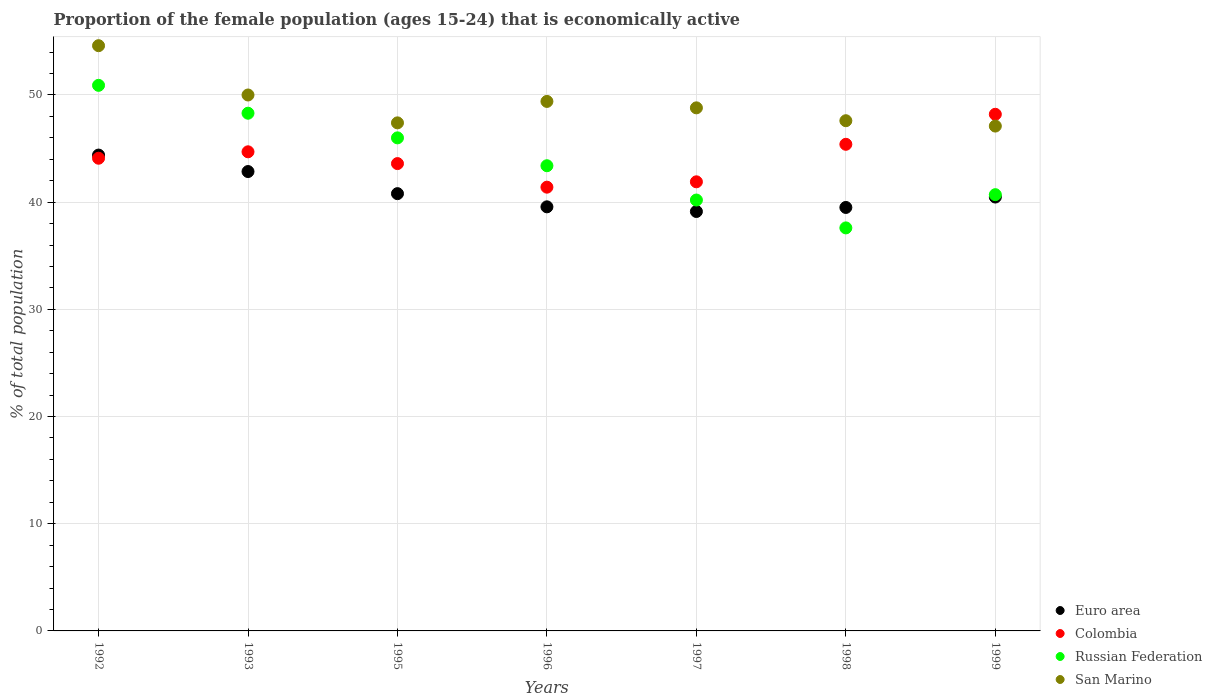How many different coloured dotlines are there?
Your response must be concise. 4. Is the number of dotlines equal to the number of legend labels?
Provide a short and direct response. Yes. What is the proportion of the female population that is economically active in Colombia in 1997?
Offer a terse response. 41.9. Across all years, what is the maximum proportion of the female population that is economically active in Colombia?
Your answer should be compact. 48.2. Across all years, what is the minimum proportion of the female population that is economically active in Euro area?
Your response must be concise. 39.13. In which year was the proportion of the female population that is economically active in San Marino minimum?
Your answer should be compact. 1999. What is the total proportion of the female population that is economically active in Colombia in the graph?
Give a very brief answer. 309.3. What is the difference between the proportion of the female population that is economically active in San Marino in 1993 and that in 1995?
Offer a terse response. 2.6. What is the average proportion of the female population that is economically active in Russian Federation per year?
Provide a short and direct response. 43.87. In the year 1999, what is the difference between the proportion of the female population that is economically active in Colombia and proportion of the female population that is economically active in San Marino?
Your response must be concise. 1.1. What is the ratio of the proportion of the female population that is economically active in Euro area in 1993 to that in 1996?
Give a very brief answer. 1.08. Is the difference between the proportion of the female population that is economically active in Colombia in 1998 and 1999 greater than the difference between the proportion of the female population that is economically active in San Marino in 1998 and 1999?
Your response must be concise. No. What is the difference between the highest and the second highest proportion of the female population that is economically active in Russian Federation?
Offer a very short reply. 2.6. What is the difference between the highest and the lowest proportion of the female population that is economically active in Colombia?
Offer a very short reply. 6.8. Does the proportion of the female population that is economically active in Colombia monotonically increase over the years?
Provide a succinct answer. No. How many dotlines are there?
Keep it short and to the point. 4. How many legend labels are there?
Make the answer very short. 4. What is the title of the graph?
Make the answer very short. Proportion of the female population (ages 15-24) that is economically active. Does "Liechtenstein" appear as one of the legend labels in the graph?
Provide a succinct answer. No. What is the label or title of the Y-axis?
Offer a terse response. % of total population. What is the % of total population in Euro area in 1992?
Provide a short and direct response. 44.39. What is the % of total population of Colombia in 1992?
Your answer should be very brief. 44.1. What is the % of total population in Russian Federation in 1992?
Offer a terse response. 50.9. What is the % of total population of San Marino in 1992?
Provide a short and direct response. 54.6. What is the % of total population of Euro area in 1993?
Offer a very short reply. 42.86. What is the % of total population of Colombia in 1993?
Offer a terse response. 44.7. What is the % of total population in Russian Federation in 1993?
Offer a very short reply. 48.3. What is the % of total population in Euro area in 1995?
Offer a very short reply. 40.8. What is the % of total population in Colombia in 1995?
Ensure brevity in your answer.  43.6. What is the % of total population of San Marino in 1995?
Offer a very short reply. 47.4. What is the % of total population in Euro area in 1996?
Your response must be concise. 39.57. What is the % of total population of Colombia in 1996?
Offer a terse response. 41.4. What is the % of total population in Russian Federation in 1996?
Provide a short and direct response. 43.4. What is the % of total population of San Marino in 1996?
Ensure brevity in your answer.  49.4. What is the % of total population in Euro area in 1997?
Your answer should be compact. 39.13. What is the % of total population of Colombia in 1997?
Your response must be concise. 41.9. What is the % of total population of Russian Federation in 1997?
Keep it short and to the point. 40.2. What is the % of total population in San Marino in 1997?
Ensure brevity in your answer.  48.8. What is the % of total population in Euro area in 1998?
Keep it short and to the point. 39.51. What is the % of total population in Colombia in 1998?
Keep it short and to the point. 45.4. What is the % of total population in Russian Federation in 1998?
Ensure brevity in your answer.  37.6. What is the % of total population of San Marino in 1998?
Your answer should be compact. 47.6. What is the % of total population in Euro area in 1999?
Offer a terse response. 40.48. What is the % of total population of Colombia in 1999?
Offer a terse response. 48.2. What is the % of total population in Russian Federation in 1999?
Keep it short and to the point. 40.7. What is the % of total population of San Marino in 1999?
Offer a terse response. 47.1. Across all years, what is the maximum % of total population in Euro area?
Your response must be concise. 44.39. Across all years, what is the maximum % of total population in Colombia?
Give a very brief answer. 48.2. Across all years, what is the maximum % of total population of Russian Federation?
Provide a short and direct response. 50.9. Across all years, what is the maximum % of total population in San Marino?
Your answer should be very brief. 54.6. Across all years, what is the minimum % of total population of Euro area?
Your response must be concise. 39.13. Across all years, what is the minimum % of total population in Colombia?
Ensure brevity in your answer.  41.4. Across all years, what is the minimum % of total population of Russian Federation?
Offer a terse response. 37.6. Across all years, what is the minimum % of total population in San Marino?
Provide a short and direct response. 47.1. What is the total % of total population of Euro area in the graph?
Make the answer very short. 286.73. What is the total % of total population in Colombia in the graph?
Your answer should be compact. 309.3. What is the total % of total population in Russian Federation in the graph?
Offer a terse response. 307.1. What is the total % of total population in San Marino in the graph?
Provide a succinct answer. 344.9. What is the difference between the % of total population of Euro area in 1992 and that in 1993?
Your answer should be very brief. 1.54. What is the difference between the % of total population in Colombia in 1992 and that in 1993?
Provide a succinct answer. -0.6. What is the difference between the % of total population of Russian Federation in 1992 and that in 1993?
Ensure brevity in your answer.  2.6. What is the difference between the % of total population of San Marino in 1992 and that in 1993?
Your response must be concise. 4.6. What is the difference between the % of total population in Euro area in 1992 and that in 1995?
Make the answer very short. 3.6. What is the difference between the % of total population in Colombia in 1992 and that in 1995?
Give a very brief answer. 0.5. What is the difference between the % of total population in Euro area in 1992 and that in 1996?
Keep it short and to the point. 4.83. What is the difference between the % of total population in Colombia in 1992 and that in 1996?
Your answer should be compact. 2.7. What is the difference between the % of total population of Euro area in 1992 and that in 1997?
Provide a succinct answer. 5.26. What is the difference between the % of total population in Colombia in 1992 and that in 1997?
Make the answer very short. 2.2. What is the difference between the % of total population of Euro area in 1992 and that in 1998?
Your answer should be very brief. 4.89. What is the difference between the % of total population in San Marino in 1992 and that in 1998?
Provide a short and direct response. 7. What is the difference between the % of total population in Euro area in 1992 and that in 1999?
Ensure brevity in your answer.  3.92. What is the difference between the % of total population of Euro area in 1993 and that in 1995?
Provide a short and direct response. 2.06. What is the difference between the % of total population of Colombia in 1993 and that in 1995?
Your response must be concise. 1.1. What is the difference between the % of total population in Russian Federation in 1993 and that in 1995?
Give a very brief answer. 2.3. What is the difference between the % of total population in Euro area in 1993 and that in 1996?
Your answer should be very brief. 3.29. What is the difference between the % of total population of Russian Federation in 1993 and that in 1996?
Provide a succinct answer. 4.9. What is the difference between the % of total population of Euro area in 1993 and that in 1997?
Ensure brevity in your answer.  3.73. What is the difference between the % of total population of Euro area in 1993 and that in 1998?
Your response must be concise. 3.35. What is the difference between the % of total population of Colombia in 1993 and that in 1998?
Give a very brief answer. -0.7. What is the difference between the % of total population of San Marino in 1993 and that in 1998?
Ensure brevity in your answer.  2.4. What is the difference between the % of total population of Euro area in 1993 and that in 1999?
Make the answer very short. 2.38. What is the difference between the % of total population in Colombia in 1993 and that in 1999?
Give a very brief answer. -3.5. What is the difference between the % of total population of Russian Federation in 1993 and that in 1999?
Ensure brevity in your answer.  7.6. What is the difference between the % of total population in San Marino in 1993 and that in 1999?
Give a very brief answer. 2.9. What is the difference between the % of total population in Euro area in 1995 and that in 1996?
Make the answer very short. 1.23. What is the difference between the % of total population in Euro area in 1995 and that in 1997?
Your answer should be compact. 1.67. What is the difference between the % of total population in Colombia in 1995 and that in 1997?
Provide a succinct answer. 1.7. What is the difference between the % of total population of Russian Federation in 1995 and that in 1997?
Provide a short and direct response. 5.8. What is the difference between the % of total population of Euro area in 1995 and that in 1998?
Your answer should be compact. 1.29. What is the difference between the % of total population in Colombia in 1995 and that in 1998?
Ensure brevity in your answer.  -1.8. What is the difference between the % of total population in San Marino in 1995 and that in 1998?
Give a very brief answer. -0.2. What is the difference between the % of total population of Euro area in 1995 and that in 1999?
Provide a succinct answer. 0.32. What is the difference between the % of total population in Colombia in 1995 and that in 1999?
Your response must be concise. -4.6. What is the difference between the % of total population in San Marino in 1995 and that in 1999?
Make the answer very short. 0.3. What is the difference between the % of total population in Euro area in 1996 and that in 1997?
Offer a terse response. 0.44. What is the difference between the % of total population in Colombia in 1996 and that in 1997?
Offer a terse response. -0.5. What is the difference between the % of total population of Russian Federation in 1996 and that in 1997?
Your response must be concise. 3.2. What is the difference between the % of total population of Euro area in 1996 and that in 1998?
Your answer should be very brief. 0.06. What is the difference between the % of total population of Colombia in 1996 and that in 1998?
Your response must be concise. -4. What is the difference between the % of total population in Russian Federation in 1996 and that in 1998?
Provide a short and direct response. 5.8. What is the difference between the % of total population in Euro area in 1996 and that in 1999?
Your answer should be compact. -0.91. What is the difference between the % of total population of Russian Federation in 1996 and that in 1999?
Ensure brevity in your answer.  2.7. What is the difference between the % of total population of Euro area in 1997 and that in 1998?
Provide a succinct answer. -0.38. What is the difference between the % of total population in San Marino in 1997 and that in 1998?
Your response must be concise. 1.2. What is the difference between the % of total population of Euro area in 1997 and that in 1999?
Your response must be concise. -1.35. What is the difference between the % of total population of Russian Federation in 1997 and that in 1999?
Your response must be concise. -0.5. What is the difference between the % of total population in Euro area in 1998 and that in 1999?
Give a very brief answer. -0.97. What is the difference between the % of total population in Colombia in 1998 and that in 1999?
Your answer should be very brief. -2.8. What is the difference between the % of total population in San Marino in 1998 and that in 1999?
Make the answer very short. 0.5. What is the difference between the % of total population of Euro area in 1992 and the % of total population of Colombia in 1993?
Your response must be concise. -0.31. What is the difference between the % of total population of Euro area in 1992 and the % of total population of Russian Federation in 1993?
Your response must be concise. -3.91. What is the difference between the % of total population of Euro area in 1992 and the % of total population of San Marino in 1993?
Make the answer very short. -5.61. What is the difference between the % of total population of Colombia in 1992 and the % of total population of Russian Federation in 1993?
Ensure brevity in your answer.  -4.2. What is the difference between the % of total population in Colombia in 1992 and the % of total population in San Marino in 1993?
Your answer should be compact. -5.9. What is the difference between the % of total population of Euro area in 1992 and the % of total population of Colombia in 1995?
Give a very brief answer. 0.79. What is the difference between the % of total population of Euro area in 1992 and the % of total population of Russian Federation in 1995?
Keep it short and to the point. -1.61. What is the difference between the % of total population in Euro area in 1992 and the % of total population in San Marino in 1995?
Provide a short and direct response. -3.01. What is the difference between the % of total population of Colombia in 1992 and the % of total population of Russian Federation in 1995?
Offer a very short reply. -1.9. What is the difference between the % of total population of Colombia in 1992 and the % of total population of San Marino in 1995?
Offer a terse response. -3.3. What is the difference between the % of total population in Russian Federation in 1992 and the % of total population in San Marino in 1995?
Make the answer very short. 3.5. What is the difference between the % of total population of Euro area in 1992 and the % of total population of Colombia in 1996?
Keep it short and to the point. 2.99. What is the difference between the % of total population of Euro area in 1992 and the % of total population of San Marino in 1996?
Offer a very short reply. -5.01. What is the difference between the % of total population of Russian Federation in 1992 and the % of total population of San Marino in 1996?
Ensure brevity in your answer.  1.5. What is the difference between the % of total population of Euro area in 1992 and the % of total population of Colombia in 1997?
Offer a terse response. 2.49. What is the difference between the % of total population of Euro area in 1992 and the % of total population of Russian Federation in 1997?
Give a very brief answer. 4.19. What is the difference between the % of total population of Euro area in 1992 and the % of total population of San Marino in 1997?
Make the answer very short. -4.41. What is the difference between the % of total population in Colombia in 1992 and the % of total population in Russian Federation in 1997?
Make the answer very short. 3.9. What is the difference between the % of total population in Euro area in 1992 and the % of total population in Colombia in 1998?
Give a very brief answer. -1.01. What is the difference between the % of total population in Euro area in 1992 and the % of total population in Russian Federation in 1998?
Make the answer very short. 6.79. What is the difference between the % of total population in Euro area in 1992 and the % of total population in San Marino in 1998?
Your response must be concise. -3.21. What is the difference between the % of total population in Colombia in 1992 and the % of total population in Russian Federation in 1998?
Give a very brief answer. 6.5. What is the difference between the % of total population of Euro area in 1992 and the % of total population of Colombia in 1999?
Your answer should be compact. -3.81. What is the difference between the % of total population in Euro area in 1992 and the % of total population in Russian Federation in 1999?
Ensure brevity in your answer.  3.69. What is the difference between the % of total population of Euro area in 1992 and the % of total population of San Marino in 1999?
Keep it short and to the point. -2.71. What is the difference between the % of total population of Colombia in 1992 and the % of total population of San Marino in 1999?
Provide a short and direct response. -3. What is the difference between the % of total population of Euro area in 1993 and the % of total population of Colombia in 1995?
Offer a very short reply. -0.74. What is the difference between the % of total population in Euro area in 1993 and the % of total population in Russian Federation in 1995?
Make the answer very short. -3.14. What is the difference between the % of total population in Euro area in 1993 and the % of total population in San Marino in 1995?
Give a very brief answer. -4.54. What is the difference between the % of total population of Colombia in 1993 and the % of total population of San Marino in 1995?
Keep it short and to the point. -2.7. What is the difference between the % of total population of Euro area in 1993 and the % of total population of Colombia in 1996?
Your answer should be very brief. 1.46. What is the difference between the % of total population of Euro area in 1993 and the % of total population of Russian Federation in 1996?
Your answer should be compact. -0.54. What is the difference between the % of total population of Euro area in 1993 and the % of total population of San Marino in 1996?
Offer a very short reply. -6.54. What is the difference between the % of total population of Colombia in 1993 and the % of total population of San Marino in 1996?
Give a very brief answer. -4.7. What is the difference between the % of total population of Russian Federation in 1993 and the % of total population of San Marino in 1996?
Offer a terse response. -1.1. What is the difference between the % of total population in Euro area in 1993 and the % of total population in Colombia in 1997?
Your answer should be compact. 0.96. What is the difference between the % of total population in Euro area in 1993 and the % of total population in Russian Federation in 1997?
Ensure brevity in your answer.  2.66. What is the difference between the % of total population of Euro area in 1993 and the % of total population of San Marino in 1997?
Ensure brevity in your answer.  -5.94. What is the difference between the % of total population of Colombia in 1993 and the % of total population of Russian Federation in 1997?
Offer a very short reply. 4.5. What is the difference between the % of total population in Colombia in 1993 and the % of total population in San Marino in 1997?
Offer a very short reply. -4.1. What is the difference between the % of total population in Russian Federation in 1993 and the % of total population in San Marino in 1997?
Offer a terse response. -0.5. What is the difference between the % of total population in Euro area in 1993 and the % of total population in Colombia in 1998?
Your answer should be very brief. -2.54. What is the difference between the % of total population in Euro area in 1993 and the % of total population in Russian Federation in 1998?
Give a very brief answer. 5.26. What is the difference between the % of total population of Euro area in 1993 and the % of total population of San Marino in 1998?
Provide a short and direct response. -4.74. What is the difference between the % of total population in Colombia in 1993 and the % of total population in Russian Federation in 1998?
Provide a succinct answer. 7.1. What is the difference between the % of total population in Colombia in 1993 and the % of total population in San Marino in 1998?
Your answer should be compact. -2.9. What is the difference between the % of total population in Euro area in 1993 and the % of total population in Colombia in 1999?
Provide a short and direct response. -5.34. What is the difference between the % of total population of Euro area in 1993 and the % of total population of Russian Federation in 1999?
Your response must be concise. 2.16. What is the difference between the % of total population of Euro area in 1993 and the % of total population of San Marino in 1999?
Make the answer very short. -4.24. What is the difference between the % of total population in Colombia in 1993 and the % of total population in Russian Federation in 1999?
Your answer should be compact. 4. What is the difference between the % of total population of Euro area in 1995 and the % of total population of Colombia in 1996?
Provide a short and direct response. -0.6. What is the difference between the % of total population in Euro area in 1995 and the % of total population in Russian Federation in 1996?
Your answer should be compact. -2.6. What is the difference between the % of total population of Euro area in 1995 and the % of total population of San Marino in 1996?
Offer a terse response. -8.6. What is the difference between the % of total population of Colombia in 1995 and the % of total population of Russian Federation in 1996?
Make the answer very short. 0.2. What is the difference between the % of total population in Colombia in 1995 and the % of total population in San Marino in 1996?
Provide a short and direct response. -5.8. What is the difference between the % of total population of Euro area in 1995 and the % of total population of Colombia in 1997?
Ensure brevity in your answer.  -1.1. What is the difference between the % of total population of Euro area in 1995 and the % of total population of Russian Federation in 1997?
Your answer should be compact. 0.6. What is the difference between the % of total population of Euro area in 1995 and the % of total population of San Marino in 1997?
Offer a terse response. -8. What is the difference between the % of total population of Colombia in 1995 and the % of total population of Russian Federation in 1997?
Ensure brevity in your answer.  3.4. What is the difference between the % of total population of Russian Federation in 1995 and the % of total population of San Marino in 1997?
Your answer should be very brief. -2.8. What is the difference between the % of total population in Euro area in 1995 and the % of total population in Colombia in 1998?
Give a very brief answer. -4.6. What is the difference between the % of total population in Euro area in 1995 and the % of total population in Russian Federation in 1998?
Your answer should be compact. 3.2. What is the difference between the % of total population of Euro area in 1995 and the % of total population of San Marino in 1998?
Provide a short and direct response. -6.8. What is the difference between the % of total population of Colombia in 1995 and the % of total population of Russian Federation in 1998?
Your answer should be compact. 6. What is the difference between the % of total population in Euro area in 1995 and the % of total population in Colombia in 1999?
Offer a terse response. -7.4. What is the difference between the % of total population in Euro area in 1995 and the % of total population in Russian Federation in 1999?
Offer a very short reply. 0.1. What is the difference between the % of total population in Euro area in 1995 and the % of total population in San Marino in 1999?
Make the answer very short. -6.3. What is the difference between the % of total population of Colombia in 1995 and the % of total population of Russian Federation in 1999?
Ensure brevity in your answer.  2.9. What is the difference between the % of total population of Colombia in 1995 and the % of total population of San Marino in 1999?
Your answer should be very brief. -3.5. What is the difference between the % of total population of Russian Federation in 1995 and the % of total population of San Marino in 1999?
Ensure brevity in your answer.  -1.1. What is the difference between the % of total population in Euro area in 1996 and the % of total population in Colombia in 1997?
Provide a succinct answer. -2.33. What is the difference between the % of total population of Euro area in 1996 and the % of total population of Russian Federation in 1997?
Your answer should be compact. -0.63. What is the difference between the % of total population of Euro area in 1996 and the % of total population of San Marino in 1997?
Give a very brief answer. -9.23. What is the difference between the % of total population in Colombia in 1996 and the % of total population in San Marino in 1997?
Offer a very short reply. -7.4. What is the difference between the % of total population in Euro area in 1996 and the % of total population in Colombia in 1998?
Your answer should be compact. -5.83. What is the difference between the % of total population in Euro area in 1996 and the % of total population in Russian Federation in 1998?
Make the answer very short. 1.97. What is the difference between the % of total population in Euro area in 1996 and the % of total population in San Marino in 1998?
Ensure brevity in your answer.  -8.03. What is the difference between the % of total population in Russian Federation in 1996 and the % of total population in San Marino in 1998?
Offer a terse response. -4.2. What is the difference between the % of total population in Euro area in 1996 and the % of total population in Colombia in 1999?
Make the answer very short. -8.63. What is the difference between the % of total population of Euro area in 1996 and the % of total population of Russian Federation in 1999?
Make the answer very short. -1.13. What is the difference between the % of total population of Euro area in 1996 and the % of total population of San Marino in 1999?
Make the answer very short. -7.53. What is the difference between the % of total population of Colombia in 1996 and the % of total population of San Marino in 1999?
Keep it short and to the point. -5.7. What is the difference between the % of total population of Euro area in 1997 and the % of total population of Colombia in 1998?
Your answer should be compact. -6.27. What is the difference between the % of total population in Euro area in 1997 and the % of total population in Russian Federation in 1998?
Your response must be concise. 1.53. What is the difference between the % of total population in Euro area in 1997 and the % of total population in San Marino in 1998?
Offer a very short reply. -8.47. What is the difference between the % of total population of Colombia in 1997 and the % of total population of Russian Federation in 1998?
Keep it short and to the point. 4.3. What is the difference between the % of total population of Euro area in 1997 and the % of total population of Colombia in 1999?
Your answer should be compact. -9.07. What is the difference between the % of total population in Euro area in 1997 and the % of total population in Russian Federation in 1999?
Provide a short and direct response. -1.57. What is the difference between the % of total population in Euro area in 1997 and the % of total population in San Marino in 1999?
Offer a terse response. -7.97. What is the difference between the % of total population of Colombia in 1997 and the % of total population of Russian Federation in 1999?
Your answer should be very brief. 1.2. What is the difference between the % of total population of Colombia in 1997 and the % of total population of San Marino in 1999?
Keep it short and to the point. -5.2. What is the difference between the % of total population of Euro area in 1998 and the % of total population of Colombia in 1999?
Your answer should be very brief. -8.69. What is the difference between the % of total population in Euro area in 1998 and the % of total population in Russian Federation in 1999?
Your answer should be compact. -1.19. What is the difference between the % of total population in Euro area in 1998 and the % of total population in San Marino in 1999?
Provide a succinct answer. -7.59. What is the difference between the % of total population in Russian Federation in 1998 and the % of total population in San Marino in 1999?
Provide a short and direct response. -9.5. What is the average % of total population of Euro area per year?
Give a very brief answer. 40.96. What is the average % of total population in Colombia per year?
Ensure brevity in your answer.  44.19. What is the average % of total population in Russian Federation per year?
Give a very brief answer. 43.87. What is the average % of total population in San Marino per year?
Make the answer very short. 49.27. In the year 1992, what is the difference between the % of total population in Euro area and % of total population in Colombia?
Give a very brief answer. 0.29. In the year 1992, what is the difference between the % of total population in Euro area and % of total population in Russian Federation?
Your response must be concise. -6.51. In the year 1992, what is the difference between the % of total population of Euro area and % of total population of San Marino?
Offer a very short reply. -10.21. In the year 1992, what is the difference between the % of total population of Colombia and % of total population of San Marino?
Your response must be concise. -10.5. In the year 1992, what is the difference between the % of total population of Russian Federation and % of total population of San Marino?
Keep it short and to the point. -3.7. In the year 1993, what is the difference between the % of total population of Euro area and % of total population of Colombia?
Provide a short and direct response. -1.84. In the year 1993, what is the difference between the % of total population of Euro area and % of total population of Russian Federation?
Make the answer very short. -5.44. In the year 1993, what is the difference between the % of total population of Euro area and % of total population of San Marino?
Offer a very short reply. -7.14. In the year 1993, what is the difference between the % of total population in Colombia and % of total population in San Marino?
Offer a very short reply. -5.3. In the year 1993, what is the difference between the % of total population of Russian Federation and % of total population of San Marino?
Keep it short and to the point. -1.7. In the year 1995, what is the difference between the % of total population of Euro area and % of total population of Colombia?
Provide a short and direct response. -2.8. In the year 1995, what is the difference between the % of total population in Euro area and % of total population in Russian Federation?
Offer a very short reply. -5.2. In the year 1995, what is the difference between the % of total population in Euro area and % of total population in San Marino?
Make the answer very short. -6.6. In the year 1995, what is the difference between the % of total population in Colombia and % of total population in San Marino?
Make the answer very short. -3.8. In the year 1995, what is the difference between the % of total population in Russian Federation and % of total population in San Marino?
Your answer should be compact. -1.4. In the year 1996, what is the difference between the % of total population of Euro area and % of total population of Colombia?
Make the answer very short. -1.83. In the year 1996, what is the difference between the % of total population of Euro area and % of total population of Russian Federation?
Provide a short and direct response. -3.83. In the year 1996, what is the difference between the % of total population of Euro area and % of total population of San Marino?
Keep it short and to the point. -9.83. In the year 1996, what is the difference between the % of total population in Russian Federation and % of total population in San Marino?
Offer a very short reply. -6. In the year 1997, what is the difference between the % of total population in Euro area and % of total population in Colombia?
Keep it short and to the point. -2.77. In the year 1997, what is the difference between the % of total population in Euro area and % of total population in Russian Federation?
Provide a short and direct response. -1.07. In the year 1997, what is the difference between the % of total population in Euro area and % of total population in San Marino?
Ensure brevity in your answer.  -9.67. In the year 1997, what is the difference between the % of total population in Russian Federation and % of total population in San Marino?
Provide a succinct answer. -8.6. In the year 1998, what is the difference between the % of total population in Euro area and % of total population in Colombia?
Give a very brief answer. -5.89. In the year 1998, what is the difference between the % of total population of Euro area and % of total population of Russian Federation?
Make the answer very short. 1.91. In the year 1998, what is the difference between the % of total population in Euro area and % of total population in San Marino?
Your answer should be compact. -8.09. In the year 1999, what is the difference between the % of total population of Euro area and % of total population of Colombia?
Ensure brevity in your answer.  -7.72. In the year 1999, what is the difference between the % of total population in Euro area and % of total population in Russian Federation?
Your answer should be compact. -0.22. In the year 1999, what is the difference between the % of total population of Euro area and % of total population of San Marino?
Your response must be concise. -6.62. In the year 1999, what is the difference between the % of total population in Colombia and % of total population in Russian Federation?
Provide a succinct answer. 7.5. In the year 1999, what is the difference between the % of total population in Russian Federation and % of total population in San Marino?
Give a very brief answer. -6.4. What is the ratio of the % of total population of Euro area in 1992 to that in 1993?
Give a very brief answer. 1.04. What is the ratio of the % of total population of Colombia in 1992 to that in 1993?
Your answer should be compact. 0.99. What is the ratio of the % of total population of Russian Federation in 1992 to that in 1993?
Provide a short and direct response. 1.05. What is the ratio of the % of total population of San Marino in 1992 to that in 1993?
Provide a succinct answer. 1.09. What is the ratio of the % of total population in Euro area in 1992 to that in 1995?
Give a very brief answer. 1.09. What is the ratio of the % of total population in Colombia in 1992 to that in 1995?
Offer a very short reply. 1.01. What is the ratio of the % of total population of Russian Federation in 1992 to that in 1995?
Offer a very short reply. 1.11. What is the ratio of the % of total population of San Marino in 1992 to that in 1995?
Make the answer very short. 1.15. What is the ratio of the % of total population in Euro area in 1992 to that in 1996?
Offer a very short reply. 1.12. What is the ratio of the % of total population in Colombia in 1992 to that in 1996?
Offer a terse response. 1.07. What is the ratio of the % of total population of Russian Federation in 1992 to that in 1996?
Provide a succinct answer. 1.17. What is the ratio of the % of total population of San Marino in 1992 to that in 1996?
Make the answer very short. 1.11. What is the ratio of the % of total population of Euro area in 1992 to that in 1997?
Your response must be concise. 1.13. What is the ratio of the % of total population in Colombia in 1992 to that in 1997?
Give a very brief answer. 1.05. What is the ratio of the % of total population in Russian Federation in 1992 to that in 1997?
Give a very brief answer. 1.27. What is the ratio of the % of total population in San Marino in 1992 to that in 1997?
Provide a short and direct response. 1.12. What is the ratio of the % of total population in Euro area in 1992 to that in 1998?
Offer a very short reply. 1.12. What is the ratio of the % of total population of Colombia in 1992 to that in 1998?
Ensure brevity in your answer.  0.97. What is the ratio of the % of total population of Russian Federation in 1992 to that in 1998?
Provide a succinct answer. 1.35. What is the ratio of the % of total population of San Marino in 1992 to that in 1998?
Keep it short and to the point. 1.15. What is the ratio of the % of total population in Euro area in 1992 to that in 1999?
Offer a terse response. 1.1. What is the ratio of the % of total population of Colombia in 1992 to that in 1999?
Your response must be concise. 0.91. What is the ratio of the % of total population in Russian Federation in 1992 to that in 1999?
Provide a short and direct response. 1.25. What is the ratio of the % of total population of San Marino in 1992 to that in 1999?
Your answer should be compact. 1.16. What is the ratio of the % of total population of Euro area in 1993 to that in 1995?
Offer a very short reply. 1.05. What is the ratio of the % of total population of Colombia in 1993 to that in 1995?
Offer a terse response. 1.03. What is the ratio of the % of total population in Russian Federation in 1993 to that in 1995?
Ensure brevity in your answer.  1.05. What is the ratio of the % of total population of San Marino in 1993 to that in 1995?
Offer a terse response. 1.05. What is the ratio of the % of total population in Euro area in 1993 to that in 1996?
Your answer should be very brief. 1.08. What is the ratio of the % of total population of Colombia in 1993 to that in 1996?
Make the answer very short. 1.08. What is the ratio of the % of total population of Russian Federation in 1993 to that in 1996?
Your response must be concise. 1.11. What is the ratio of the % of total population in San Marino in 1993 to that in 1996?
Make the answer very short. 1.01. What is the ratio of the % of total population in Euro area in 1993 to that in 1997?
Your response must be concise. 1.1. What is the ratio of the % of total population of Colombia in 1993 to that in 1997?
Provide a short and direct response. 1.07. What is the ratio of the % of total population of Russian Federation in 1993 to that in 1997?
Your answer should be very brief. 1.2. What is the ratio of the % of total population in San Marino in 1993 to that in 1997?
Your answer should be very brief. 1.02. What is the ratio of the % of total population of Euro area in 1993 to that in 1998?
Offer a very short reply. 1.08. What is the ratio of the % of total population in Colombia in 1993 to that in 1998?
Provide a succinct answer. 0.98. What is the ratio of the % of total population of Russian Federation in 1993 to that in 1998?
Offer a very short reply. 1.28. What is the ratio of the % of total population in San Marino in 1993 to that in 1998?
Ensure brevity in your answer.  1.05. What is the ratio of the % of total population of Euro area in 1993 to that in 1999?
Make the answer very short. 1.06. What is the ratio of the % of total population of Colombia in 1993 to that in 1999?
Offer a very short reply. 0.93. What is the ratio of the % of total population in Russian Federation in 1993 to that in 1999?
Keep it short and to the point. 1.19. What is the ratio of the % of total population in San Marino in 1993 to that in 1999?
Your answer should be compact. 1.06. What is the ratio of the % of total population of Euro area in 1995 to that in 1996?
Offer a terse response. 1.03. What is the ratio of the % of total population of Colombia in 1995 to that in 1996?
Provide a short and direct response. 1.05. What is the ratio of the % of total population of Russian Federation in 1995 to that in 1996?
Make the answer very short. 1.06. What is the ratio of the % of total population in San Marino in 1995 to that in 1996?
Ensure brevity in your answer.  0.96. What is the ratio of the % of total population in Euro area in 1995 to that in 1997?
Provide a short and direct response. 1.04. What is the ratio of the % of total population in Colombia in 1995 to that in 1997?
Provide a short and direct response. 1.04. What is the ratio of the % of total population of Russian Federation in 1995 to that in 1997?
Provide a succinct answer. 1.14. What is the ratio of the % of total population in San Marino in 1995 to that in 1997?
Keep it short and to the point. 0.97. What is the ratio of the % of total population in Euro area in 1995 to that in 1998?
Keep it short and to the point. 1.03. What is the ratio of the % of total population in Colombia in 1995 to that in 1998?
Keep it short and to the point. 0.96. What is the ratio of the % of total population of Russian Federation in 1995 to that in 1998?
Provide a succinct answer. 1.22. What is the ratio of the % of total population in Colombia in 1995 to that in 1999?
Make the answer very short. 0.9. What is the ratio of the % of total population in Russian Federation in 1995 to that in 1999?
Offer a terse response. 1.13. What is the ratio of the % of total population in San Marino in 1995 to that in 1999?
Offer a terse response. 1.01. What is the ratio of the % of total population of Euro area in 1996 to that in 1997?
Provide a succinct answer. 1.01. What is the ratio of the % of total population in Russian Federation in 1996 to that in 1997?
Offer a very short reply. 1.08. What is the ratio of the % of total population in San Marino in 1996 to that in 1997?
Make the answer very short. 1.01. What is the ratio of the % of total population of Euro area in 1996 to that in 1998?
Keep it short and to the point. 1. What is the ratio of the % of total population in Colombia in 1996 to that in 1998?
Provide a succinct answer. 0.91. What is the ratio of the % of total population of Russian Federation in 1996 to that in 1998?
Make the answer very short. 1.15. What is the ratio of the % of total population in San Marino in 1996 to that in 1998?
Make the answer very short. 1.04. What is the ratio of the % of total population of Euro area in 1996 to that in 1999?
Make the answer very short. 0.98. What is the ratio of the % of total population in Colombia in 1996 to that in 1999?
Offer a very short reply. 0.86. What is the ratio of the % of total population in Russian Federation in 1996 to that in 1999?
Provide a succinct answer. 1.07. What is the ratio of the % of total population of San Marino in 1996 to that in 1999?
Provide a succinct answer. 1.05. What is the ratio of the % of total population in Colombia in 1997 to that in 1998?
Your response must be concise. 0.92. What is the ratio of the % of total population of Russian Federation in 1997 to that in 1998?
Keep it short and to the point. 1.07. What is the ratio of the % of total population of San Marino in 1997 to that in 1998?
Provide a short and direct response. 1.03. What is the ratio of the % of total population of Euro area in 1997 to that in 1999?
Your answer should be compact. 0.97. What is the ratio of the % of total population of Colombia in 1997 to that in 1999?
Provide a succinct answer. 0.87. What is the ratio of the % of total population of San Marino in 1997 to that in 1999?
Offer a very short reply. 1.04. What is the ratio of the % of total population in Euro area in 1998 to that in 1999?
Keep it short and to the point. 0.98. What is the ratio of the % of total population in Colombia in 1998 to that in 1999?
Ensure brevity in your answer.  0.94. What is the ratio of the % of total population in Russian Federation in 1998 to that in 1999?
Your response must be concise. 0.92. What is the ratio of the % of total population in San Marino in 1998 to that in 1999?
Offer a terse response. 1.01. What is the difference between the highest and the second highest % of total population in Euro area?
Your answer should be compact. 1.54. What is the difference between the highest and the second highest % of total population of Colombia?
Provide a short and direct response. 2.8. What is the difference between the highest and the second highest % of total population in Russian Federation?
Make the answer very short. 2.6. What is the difference between the highest and the second highest % of total population in San Marino?
Provide a succinct answer. 4.6. What is the difference between the highest and the lowest % of total population of Euro area?
Your answer should be compact. 5.26. What is the difference between the highest and the lowest % of total population in Colombia?
Offer a very short reply. 6.8. What is the difference between the highest and the lowest % of total population of Russian Federation?
Provide a short and direct response. 13.3. 